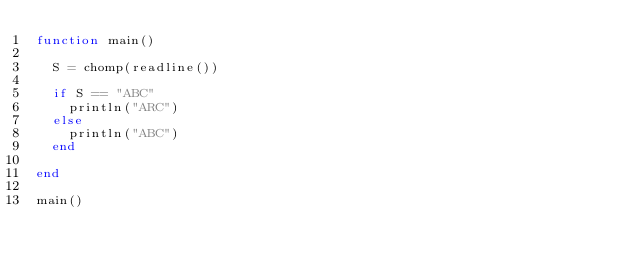<code> <loc_0><loc_0><loc_500><loc_500><_Julia_>function main()
  
  S = chomp(readline())
  
  if S == "ABC"
    println("ARC")
  else
    println("ABC")
  end
  
end

main()</code> 